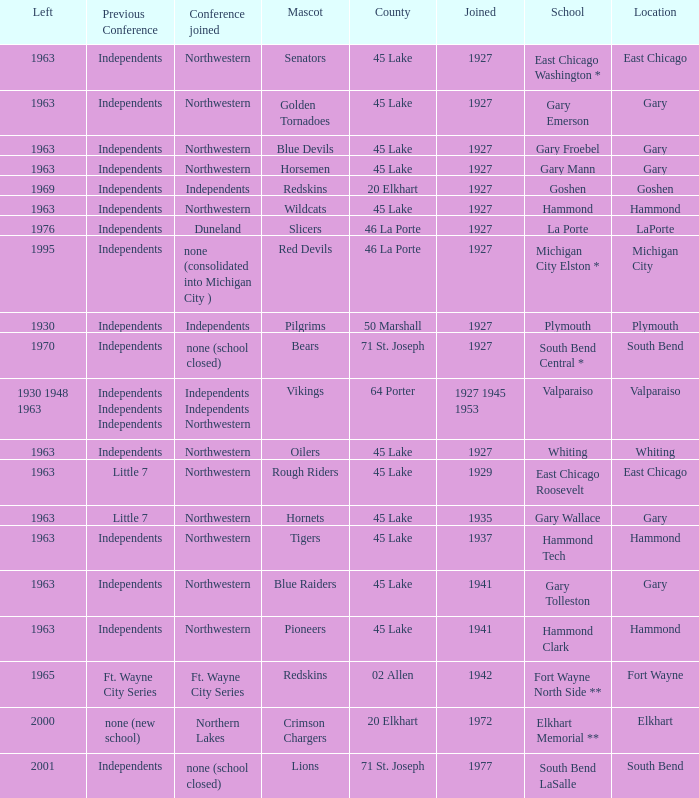Which conference held at School of whiting? Independents. 